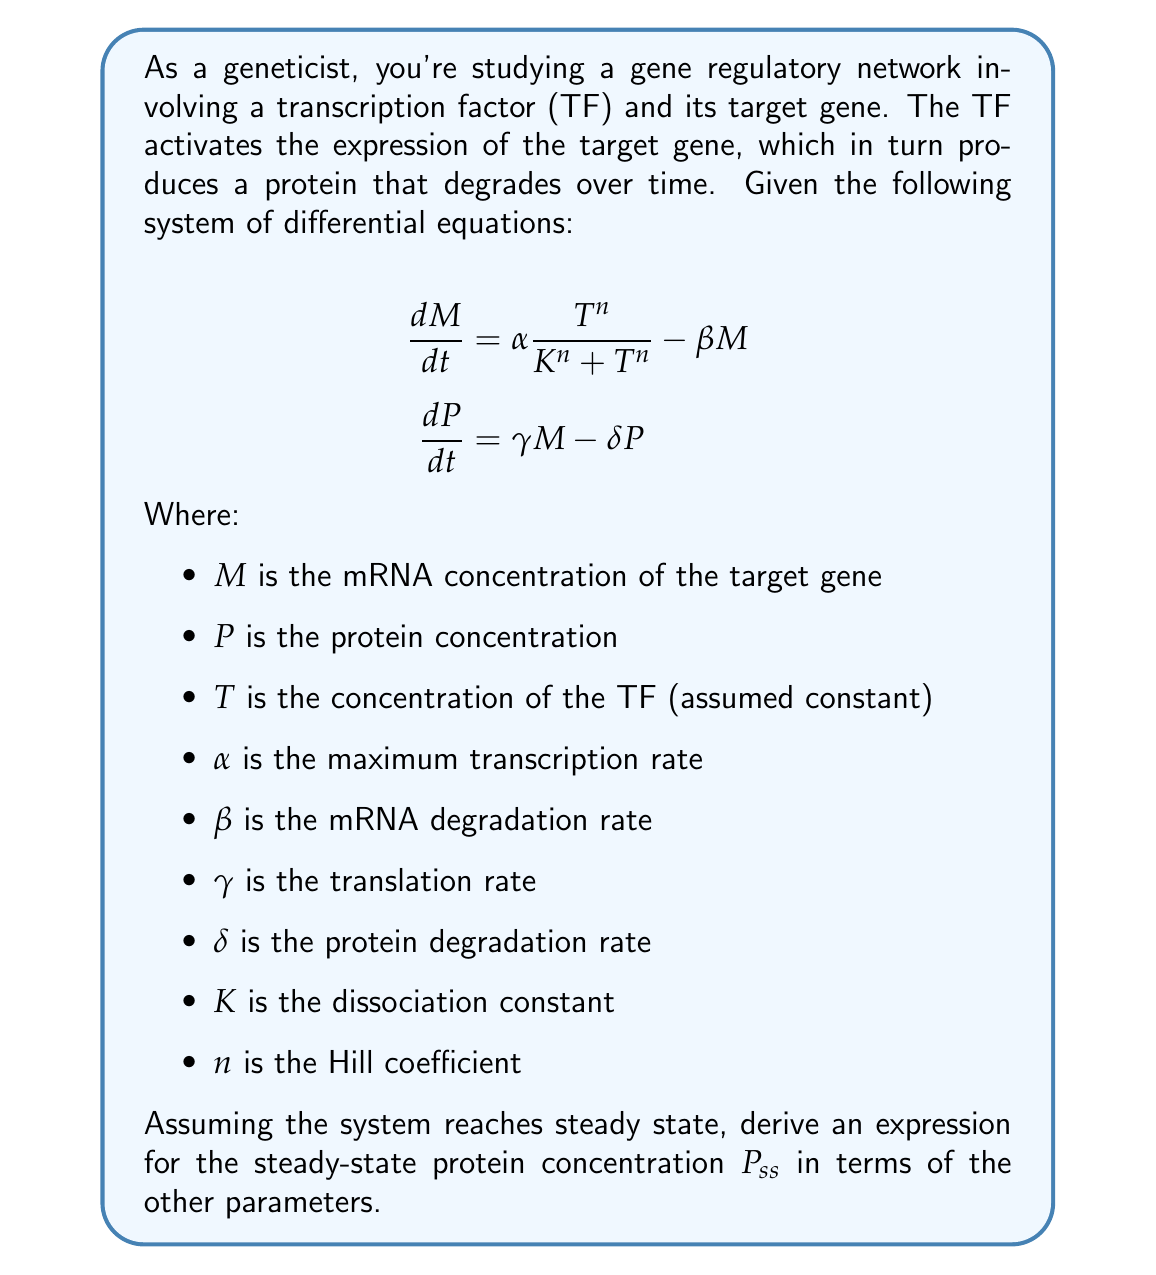What is the answer to this math problem? To solve this problem, we'll follow these steps:

1) At steady state, the concentrations don't change over time, so we set both derivatives to zero:

   $$\begin{align}
   \frac{dM}{dt} &= 0 = \alpha \frac{T^n}{K^n + T^n} - \beta M_{ss} \\
   \frac{dP}{dt} &= 0 = \gamma M_{ss} - \delta P_{ss}
   \end{align}$$

2) From the first equation, we can express $M_{ss}$:

   $$M_{ss} = \frac{\alpha}{\beta} \frac{T^n}{K^n + T^n}$$

3) Substitute this into the second equation:

   $$0 = \gamma \left(\frac{\alpha}{\beta} \frac{T^n}{K^n + T^n}\right) - \delta P_{ss}$$

4) Solve for $P_{ss}$:

   $$P_{ss} = \frac{\gamma}{\delta} \left(\frac{\alpha}{\beta} \frac{T^n}{K^n + T^n}\right)$$

5) Simplify by grouping constants:

   $$P_{ss} = \frac{\alpha \gamma}{\beta \delta} \frac{T^n}{K^n + T^n}$$

This expression gives the steady-state protein concentration in terms of the other parameters of the system.
Answer: $P_{ss} = \frac{\alpha \gamma}{\beta \delta} \frac{T^n}{K^n + T^n}$ 